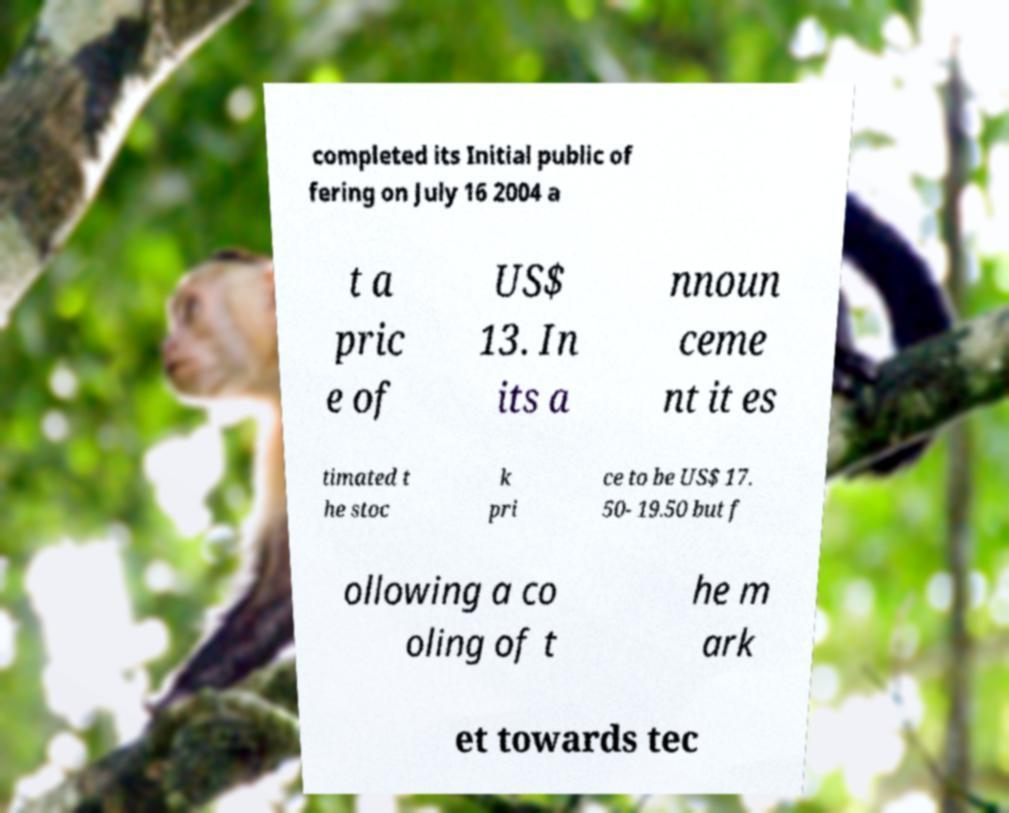What messages or text are displayed in this image? I need them in a readable, typed format. completed its Initial public of fering on July 16 2004 a t a pric e of US$ 13. In its a nnoun ceme nt it es timated t he stoc k pri ce to be US$ 17. 50- 19.50 but f ollowing a co oling of t he m ark et towards tec 